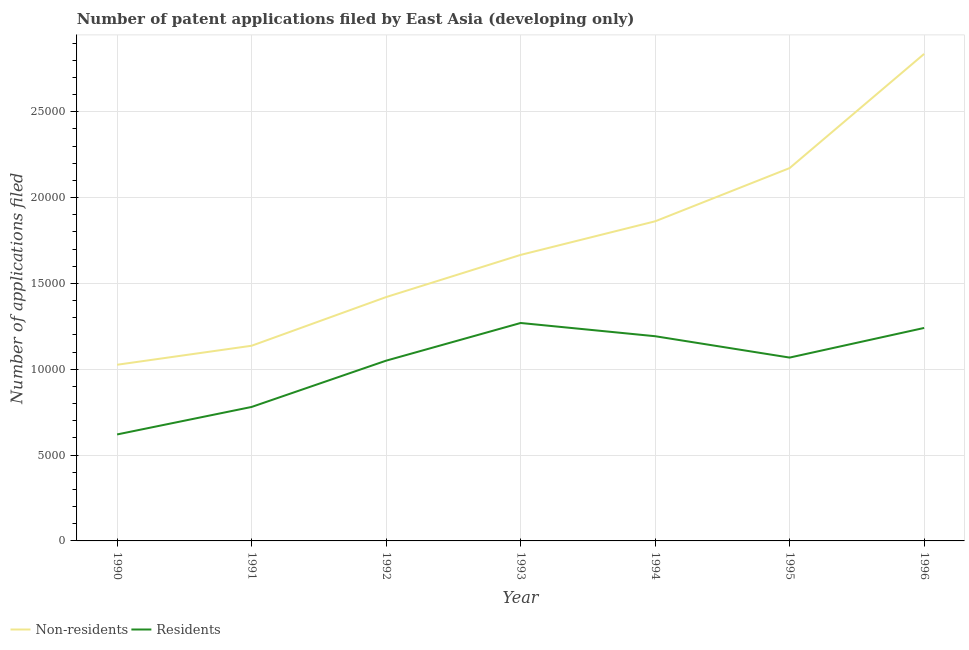How many different coloured lines are there?
Keep it short and to the point. 2. Does the line corresponding to number of patent applications by non residents intersect with the line corresponding to number of patent applications by residents?
Ensure brevity in your answer.  No. What is the number of patent applications by residents in 1996?
Your answer should be compact. 1.24e+04. Across all years, what is the maximum number of patent applications by residents?
Provide a succinct answer. 1.27e+04. Across all years, what is the minimum number of patent applications by non residents?
Provide a succinct answer. 1.03e+04. What is the total number of patent applications by residents in the graph?
Ensure brevity in your answer.  7.22e+04. What is the difference between the number of patent applications by non residents in 1990 and that in 1995?
Your response must be concise. -1.15e+04. What is the difference between the number of patent applications by residents in 1992 and the number of patent applications by non residents in 1995?
Offer a terse response. -1.12e+04. What is the average number of patent applications by residents per year?
Provide a succinct answer. 1.03e+04. In the year 1993, what is the difference between the number of patent applications by non residents and number of patent applications by residents?
Make the answer very short. 3966. What is the ratio of the number of patent applications by non residents in 1993 to that in 1994?
Your answer should be very brief. 0.89. Is the number of patent applications by residents in 1990 less than that in 1992?
Your answer should be very brief. Yes. What is the difference between the highest and the second highest number of patent applications by residents?
Keep it short and to the point. 289. What is the difference between the highest and the lowest number of patent applications by residents?
Your answer should be very brief. 6493. Is the sum of the number of patent applications by residents in 1991 and 1994 greater than the maximum number of patent applications by non residents across all years?
Offer a terse response. No. Is the number of patent applications by residents strictly greater than the number of patent applications by non residents over the years?
Keep it short and to the point. No. Is the number of patent applications by non residents strictly less than the number of patent applications by residents over the years?
Offer a very short reply. No. How many lines are there?
Keep it short and to the point. 2. Are the values on the major ticks of Y-axis written in scientific E-notation?
Your response must be concise. No. Does the graph contain grids?
Make the answer very short. Yes. Where does the legend appear in the graph?
Your answer should be compact. Bottom left. What is the title of the graph?
Your answer should be compact. Number of patent applications filed by East Asia (developing only). Does "Travel services" appear as one of the legend labels in the graph?
Your answer should be very brief. No. What is the label or title of the X-axis?
Ensure brevity in your answer.  Year. What is the label or title of the Y-axis?
Offer a very short reply. Number of applications filed. What is the Number of applications filed in Non-residents in 1990?
Offer a very short reply. 1.03e+04. What is the Number of applications filed of Residents in 1990?
Ensure brevity in your answer.  6202. What is the Number of applications filed in Non-residents in 1991?
Make the answer very short. 1.14e+04. What is the Number of applications filed in Residents in 1991?
Offer a terse response. 7804. What is the Number of applications filed of Non-residents in 1992?
Your answer should be compact. 1.42e+04. What is the Number of applications filed in Residents in 1992?
Keep it short and to the point. 1.05e+04. What is the Number of applications filed in Non-residents in 1993?
Give a very brief answer. 1.67e+04. What is the Number of applications filed in Residents in 1993?
Offer a very short reply. 1.27e+04. What is the Number of applications filed of Non-residents in 1994?
Offer a terse response. 1.86e+04. What is the Number of applications filed in Residents in 1994?
Provide a short and direct response. 1.19e+04. What is the Number of applications filed of Non-residents in 1995?
Your answer should be very brief. 2.17e+04. What is the Number of applications filed of Residents in 1995?
Your response must be concise. 1.07e+04. What is the Number of applications filed in Non-residents in 1996?
Give a very brief answer. 2.84e+04. What is the Number of applications filed in Residents in 1996?
Make the answer very short. 1.24e+04. Across all years, what is the maximum Number of applications filed in Non-residents?
Offer a very short reply. 2.84e+04. Across all years, what is the maximum Number of applications filed in Residents?
Your answer should be very brief. 1.27e+04. Across all years, what is the minimum Number of applications filed of Non-residents?
Keep it short and to the point. 1.03e+04. Across all years, what is the minimum Number of applications filed in Residents?
Your response must be concise. 6202. What is the total Number of applications filed in Non-residents in the graph?
Offer a very short reply. 1.21e+05. What is the total Number of applications filed in Residents in the graph?
Make the answer very short. 7.22e+04. What is the difference between the Number of applications filed in Non-residents in 1990 and that in 1991?
Provide a short and direct response. -1107. What is the difference between the Number of applications filed of Residents in 1990 and that in 1991?
Offer a terse response. -1602. What is the difference between the Number of applications filed in Non-residents in 1990 and that in 1992?
Offer a very short reply. -3942. What is the difference between the Number of applications filed of Residents in 1990 and that in 1992?
Your answer should be very brief. -4298. What is the difference between the Number of applications filed in Non-residents in 1990 and that in 1993?
Make the answer very short. -6399. What is the difference between the Number of applications filed in Residents in 1990 and that in 1993?
Your response must be concise. -6493. What is the difference between the Number of applications filed in Non-residents in 1990 and that in 1994?
Provide a succinct answer. -8355. What is the difference between the Number of applications filed in Residents in 1990 and that in 1994?
Your answer should be compact. -5722. What is the difference between the Number of applications filed of Non-residents in 1990 and that in 1995?
Give a very brief answer. -1.15e+04. What is the difference between the Number of applications filed of Residents in 1990 and that in 1995?
Offer a terse response. -4478. What is the difference between the Number of applications filed of Non-residents in 1990 and that in 1996?
Keep it short and to the point. -1.81e+04. What is the difference between the Number of applications filed of Residents in 1990 and that in 1996?
Your answer should be very brief. -6204. What is the difference between the Number of applications filed of Non-residents in 1991 and that in 1992?
Keep it short and to the point. -2835. What is the difference between the Number of applications filed of Residents in 1991 and that in 1992?
Offer a very short reply. -2696. What is the difference between the Number of applications filed in Non-residents in 1991 and that in 1993?
Make the answer very short. -5292. What is the difference between the Number of applications filed in Residents in 1991 and that in 1993?
Keep it short and to the point. -4891. What is the difference between the Number of applications filed in Non-residents in 1991 and that in 1994?
Offer a very short reply. -7248. What is the difference between the Number of applications filed of Residents in 1991 and that in 1994?
Offer a very short reply. -4120. What is the difference between the Number of applications filed in Non-residents in 1991 and that in 1995?
Offer a terse response. -1.04e+04. What is the difference between the Number of applications filed of Residents in 1991 and that in 1995?
Give a very brief answer. -2876. What is the difference between the Number of applications filed of Non-residents in 1991 and that in 1996?
Provide a succinct answer. -1.70e+04. What is the difference between the Number of applications filed in Residents in 1991 and that in 1996?
Provide a short and direct response. -4602. What is the difference between the Number of applications filed in Non-residents in 1992 and that in 1993?
Your answer should be compact. -2457. What is the difference between the Number of applications filed of Residents in 1992 and that in 1993?
Keep it short and to the point. -2195. What is the difference between the Number of applications filed of Non-residents in 1992 and that in 1994?
Your answer should be very brief. -4413. What is the difference between the Number of applications filed in Residents in 1992 and that in 1994?
Your answer should be very brief. -1424. What is the difference between the Number of applications filed of Non-residents in 1992 and that in 1995?
Your answer should be compact. -7515. What is the difference between the Number of applications filed of Residents in 1992 and that in 1995?
Provide a short and direct response. -180. What is the difference between the Number of applications filed of Non-residents in 1992 and that in 1996?
Your response must be concise. -1.42e+04. What is the difference between the Number of applications filed of Residents in 1992 and that in 1996?
Give a very brief answer. -1906. What is the difference between the Number of applications filed of Non-residents in 1993 and that in 1994?
Make the answer very short. -1956. What is the difference between the Number of applications filed in Residents in 1993 and that in 1994?
Provide a short and direct response. 771. What is the difference between the Number of applications filed of Non-residents in 1993 and that in 1995?
Provide a succinct answer. -5058. What is the difference between the Number of applications filed of Residents in 1993 and that in 1995?
Give a very brief answer. 2015. What is the difference between the Number of applications filed in Non-residents in 1993 and that in 1996?
Keep it short and to the point. -1.17e+04. What is the difference between the Number of applications filed in Residents in 1993 and that in 1996?
Provide a short and direct response. 289. What is the difference between the Number of applications filed of Non-residents in 1994 and that in 1995?
Your answer should be very brief. -3102. What is the difference between the Number of applications filed of Residents in 1994 and that in 1995?
Give a very brief answer. 1244. What is the difference between the Number of applications filed in Non-residents in 1994 and that in 1996?
Provide a succinct answer. -9752. What is the difference between the Number of applications filed in Residents in 1994 and that in 1996?
Your answer should be compact. -482. What is the difference between the Number of applications filed of Non-residents in 1995 and that in 1996?
Offer a very short reply. -6650. What is the difference between the Number of applications filed of Residents in 1995 and that in 1996?
Make the answer very short. -1726. What is the difference between the Number of applications filed in Non-residents in 1990 and the Number of applications filed in Residents in 1991?
Offer a very short reply. 2458. What is the difference between the Number of applications filed in Non-residents in 1990 and the Number of applications filed in Residents in 1992?
Offer a very short reply. -238. What is the difference between the Number of applications filed in Non-residents in 1990 and the Number of applications filed in Residents in 1993?
Your answer should be very brief. -2433. What is the difference between the Number of applications filed of Non-residents in 1990 and the Number of applications filed of Residents in 1994?
Ensure brevity in your answer.  -1662. What is the difference between the Number of applications filed in Non-residents in 1990 and the Number of applications filed in Residents in 1995?
Give a very brief answer. -418. What is the difference between the Number of applications filed of Non-residents in 1990 and the Number of applications filed of Residents in 1996?
Your response must be concise. -2144. What is the difference between the Number of applications filed in Non-residents in 1991 and the Number of applications filed in Residents in 1992?
Keep it short and to the point. 869. What is the difference between the Number of applications filed of Non-residents in 1991 and the Number of applications filed of Residents in 1993?
Give a very brief answer. -1326. What is the difference between the Number of applications filed of Non-residents in 1991 and the Number of applications filed of Residents in 1994?
Provide a succinct answer. -555. What is the difference between the Number of applications filed of Non-residents in 1991 and the Number of applications filed of Residents in 1995?
Offer a very short reply. 689. What is the difference between the Number of applications filed of Non-residents in 1991 and the Number of applications filed of Residents in 1996?
Provide a succinct answer. -1037. What is the difference between the Number of applications filed of Non-residents in 1992 and the Number of applications filed of Residents in 1993?
Offer a terse response. 1509. What is the difference between the Number of applications filed of Non-residents in 1992 and the Number of applications filed of Residents in 1994?
Your answer should be compact. 2280. What is the difference between the Number of applications filed in Non-residents in 1992 and the Number of applications filed in Residents in 1995?
Offer a terse response. 3524. What is the difference between the Number of applications filed in Non-residents in 1992 and the Number of applications filed in Residents in 1996?
Your response must be concise. 1798. What is the difference between the Number of applications filed in Non-residents in 1993 and the Number of applications filed in Residents in 1994?
Ensure brevity in your answer.  4737. What is the difference between the Number of applications filed in Non-residents in 1993 and the Number of applications filed in Residents in 1995?
Provide a short and direct response. 5981. What is the difference between the Number of applications filed in Non-residents in 1993 and the Number of applications filed in Residents in 1996?
Offer a very short reply. 4255. What is the difference between the Number of applications filed of Non-residents in 1994 and the Number of applications filed of Residents in 1995?
Your response must be concise. 7937. What is the difference between the Number of applications filed of Non-residents in 1994 and the Number of applications filed of Residents in 1996?
Give a very brief answer. 6211. What is the difference between the Number of applications filed of Non-residents in 1995 and the Number of applications filed of Residents in 1996?
Give a very brief answer. 9313. What is the average Number of applications filed in Non-residents per year?
Your response must be concise. 1.73e+04. What is the average Number of applications filed in Residents per year?
Ensure brevity in your answer.  1.03e+04. In the year 1990, what is the difference between the Number of applications filed of Non-residents and Number of applications filed of Residents?
Your response must be concise. 4060. In the year 1991, what is the difference between the Number of applications filed in Non-residents and Number of applications filed in Residents?
Give a very brief answer. 3565. In the year 1992, what is the difference between the Number of applications filed in Non-residents and Number of applications filed in Residents?
Your response must be concise. 3704. In the year 1993, what is the difference between the Number of applications filed of Non-residents and Number of applications filed of Residents?
Your response must be concise. 3966. In the year 1994, what is the difference between the Number of applications filed of Non-residents and Number of applications filed of Residents?
Provide a succinct answer. 6693. In the year 1995, what is the difference between the Number of applications filed in Non-residents and Number of applications filed in Residents?
Offer a very short reply. 1.10e+04. In the year 1996, what is the difference between the Number of applications filed of Non-residents and Number of applications filed of Residents?
Your answer should be compact. 1.60e+04. What is the ratio of the Number of applications filed of Non-residents in 1990 to that in 1991?
Give a very brief answer. 0.9. What is the ratio of the Number of applications filed in Residents in 1990 to that in 1991?
Make the answer very short. 0.79. What is the ratio of the Number of applications filed of Non-residents in 1990 to that in 1992?
Offer a terse response. 0.72. What is the ratio of the Number of applications filed in Residents in 1990 to that in 1992?
Give a very brief answer. 0.59. What is the ratio of the Number of applications filed of Non-residents in 1990 to that in 1993?
Keep it short and to the point. 0.62. What is the ratio of the Number of applications filed in Residents in 1990 to that in 1993?
Provide a succinct answer. 0.49. What is the ratio of the Number of applications filed in Non-residents in 1990 to that in 1994?
Give a very brief answer. 0.55. What is the ratio of the Number of applications filed of Residents in 1990 to that in 1994?
Your answer should be compact. 0.52. What is the ratio of the Number of applications filed of Non-residents in 1990 to that in 1995?
Make the answer very short. 0.47. What is the ratio of the Number of applications filed of Residents in 1990 to that in 1995?
Keep it short and to the point. 0.58. What is the ratio of the Number of applications filed in Non-residents in 1990 to that in 1996?
Provide a short and direct response. 0.36. What is the ratio of the Number of applications filed of Residents in 1990 to that in 1996?
Your answer should be compact. 0.5. What is the ratio of the Number of applications filed in Non-residents in 1991 to that in 1992?
Your answer should be compact. 0.8. What is the ratio of the Number of applications filed in Residents in 1991 to that in 1992?
Make the answer very short. 0.74. What is the ratio of the Number of applications filed in Non-residents in 1991 to that in 1993?
Offer a very short reply. 0.68. What is the ratio of the Number of applications filed of Residents in 1991 to that in 1993?
Keep it short and to the point. 0.61. What is the ratio of the Number of applications filed in Non-residents in 1991 to that in 1994?
Offer a terse response. 0.61. What is the ratio of the Number of applications filed of Residents in 1991 to that in 1994?
Keep it short and to the point. 0.65. What is the ratio of the Number of applications filed of Non-residents in 1991 to that in 1995?
Your answer should be compact. 0.52. What is the ratio of the Number of applications filed of Residents in 1991 to that in 1995?
Make the answer very short. 0.73. What is the ratio of the Number of applications filed of Non-residents in 1991 to that in 1996?
Your answer should be very brief. 0.4. What is the ratio of the Number of applications filed of Residents in 1991 to that in 1996?
Offer a terse response. 0.63. What is the ratio of the Number of applications filed of Non-residents in 1992 to that in 1993?
Keep it short and to the point. 0.85. What is the ratio of the Number of applications filed in Residents in 1992 to that in 1993?
Provide a short and direct response. 0.83. What is the ratio of the Number of applications filed in Non-residents in 1992 to that in 1994?
Give a very brief answer. 0.76. What is the ratio of the Number of applications filed in Residents in 1992 to that in 1994?
Provide a short and direct response. 0.88. What is the ratio of the Number of applications filed of Non-residents in 1992 to that in 1995?
Keep it short and to the point. 0.65. What is the ratio of the Number of applications filed in Residents in 1992 to that in 1995?
Keep it short and to the point. 0.98. What is the ratio of the Number of applications filed of Non-residents in 1992 to that in 1996?
Your answer should be very brief. 0.5. What is the ratio of the Number of applications filed in Residents in 1992 to that in 1996?
Your answer should be compact. 0.85. What is the ratio of the Number of applications filed of Non-residents in 1993 to that in 1994?
Offer a terse response. 0.89. What is the ratio of the Number of applications filed of Residents in 1993 to that in 1994?
Provide a short and direct response. 1.06. What is the ratio of the Number of applications filed in Non-residents in 1993 to that in 1995?
Ensure brevity in your answer.  0.77. What is the ratio of the Number of applications filed in Residents in 1993 to that in 1995?
Your response must be concise. 1.19. What is the ratio of the Number of applications filed of Non-residents in 1993 to that in 1996?
Your answer should be very brief. 0.59. What is the ratio of the Number of applications filed of Residents in 1993 to that in 1996?
Provide a short and direct response. 1.02. What is the ratio of the Number of applications filed of Non-residents in 1994 to that in 1995?
Keep it short and to the point. 0.86. What is the ratio of the Number of applications filed of Residents in 1994 to that in 1995?
Offer a very short reply. 1.12. What is the ratio of the Number of applications filed in Non-residents in 1994 to that in 1996?
Ensure brevity in your answer.  0.66. What is the ratio of the Number of applications filed of Residents in 1994 to that in 1996?
Keep it short and to the point. 0.96. What is the ratio of the Number of applications filed in Non-residents in 1995 to that in 1996?
Provide a short and direct response. 0.77. What is the ratio of the Number of applications filed of Residents in 1995 to that in 1996?
Ensure brevity in your answer.  0.86. What is the difference between the highest and the second highest Number of applications filed of Non-residents?
Offer a very short reply. 6650. What is the difference between the highest and the second highest Number of applications filed in Residents?
Your answer should be compact. 289. What is the difference between the highest and the lowest Number of applications filed in Non-residents?
Ensure brevity in your answer.  1.81e+04. What is the difference between the highest and the lowest Number of applications filed in Residents?
Keep it short and to the point. 6493. 